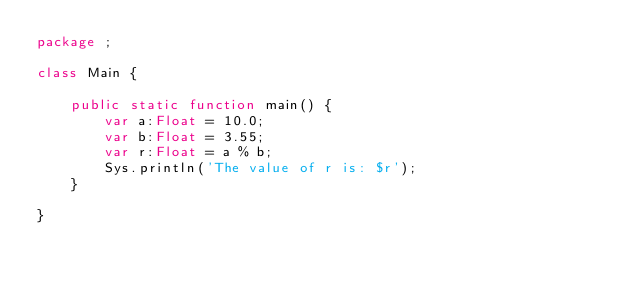Convert code to text. <code><loc_0><loc_0><loc_500><loc_500><_Haxe_>package ;

class Main {

    public static function main() {
        var a:Float = 10.0;
        var b:Float = 3.55;
        var r:Float = a % b;
        Sys.println('The value of r is: $r');
    }

}</code> 